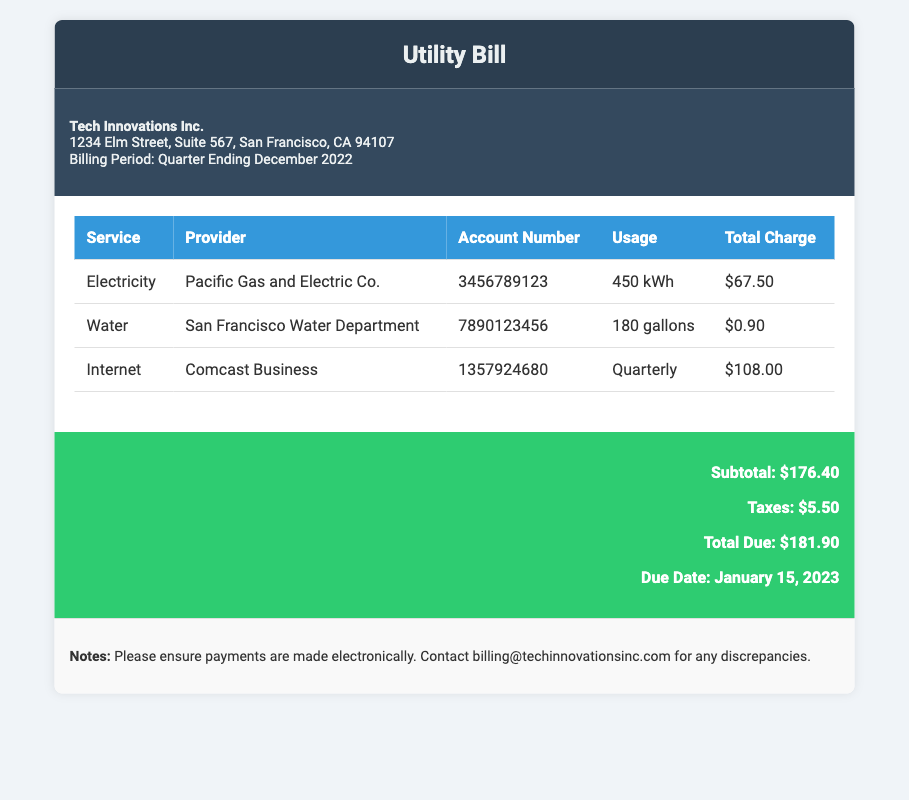What is the name of the company? The name of the company is mentioned in the header of the document as Tech Innovations Inc.
Answer: Tech Innovations Inc What is the billing period? The billing period is specified in the office details section as Quarter Ending December 2022.
Answer: Quarter Ending December 2022 Who is the electricity provider? The electricity provider is listed in the charges table under the service Electricity as Pacific Gas and Electric Co.
Answer: Pacific Gas and Electric Co What is the total charge for water usage? The total charge for water is specified in the charges table as $0.90.
Answer: $0.90 What is the total amount due? The total amount due is mentioned in the total section of the document as $181.90.
Answer: $181.90 How much taxes are included in the utility bill? The taxes included in the utility bill is indicated in the total section as $5.50.
Answer: $5.50 What service had the highest charge? The service with the highest charge is found in the charges table, which is Internet at $108.00.
Answer: Internet When is the payment due date? The due date for payment is stated in the total section as January 15, 2023.
Answer: January 15, 2023 How many gallons of water were used? The water usage is specified in the charges table as 180 gallons.
Answer: 180 gallons 